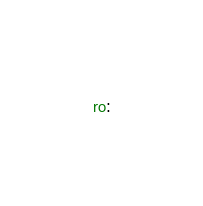<code> <loc_0><loc_0><loc_500><loc_500><_YAML_>ro:
</code> 